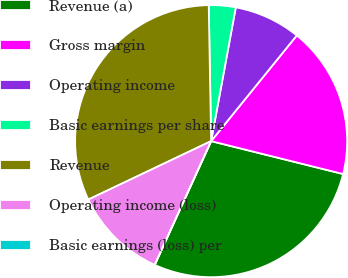Convert chart. <chart><loc_0><loc_0><loc_500><loc_500><pie_chart><fcel>Revenue (a)<fcel>Gross margin<fcel>Operating income<fcel>Basic earnings per share<fcel>Revenue<fcel>Operating income (loss)<fcel>Basic earnings (loss) per<nl><fcel>27.92%<fcel>18.05%<fcel>7.94%<fcel>3.18%<fcel>31.79%<fcel>11.12%<fcel>0.0%<nl></chart> 